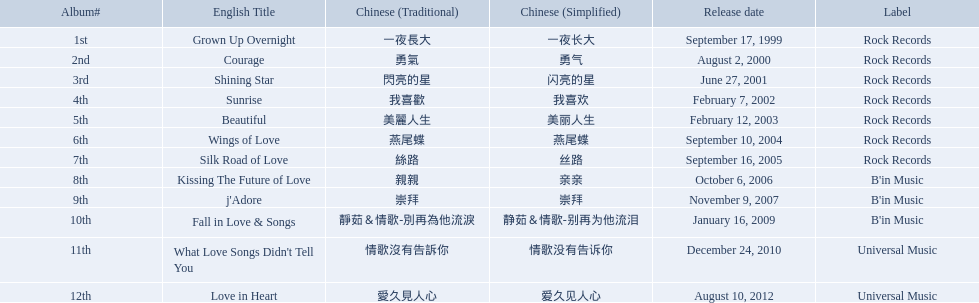Which english titles were released during even years? Courage, Sunrise, Silk Road of Love, Kissing The Future of Love, What Love Songs Didn't Tell You, Love in Heart. Out of the following, which one was released under b's in music? Kissing The Future of Love. Parse the full table in json format. {'header': ['Album#', 'English Title', 'Chinese (Traditional)', 'Chinese (Simplified)', 'Release date', 'Label'], 'rows': [['1st', 'Grown Up Overnight', '一夜長大', '一夜长大', 'September 17, 1999', 'Rock Records'], ['2nd', 'Courage', '勇氣', '勇气', 'August 2, 2000', 'Rock Records'], ['3rd', 'Shining Star', '閃亮的星', '闪亮的星', 'June 27, 2001', 'Rock Records'], ['4th', 'Sunrise', '我喜歡', '我喜欢', 'February 7, 2002', 'Rock Records'], ['5th', 'Beautiful', '美麗人生', '美丽人生', 'February 12, 2003', 'Rock Records'], ['6th', 'Wings of Love', '燕尾蝶', '燕尾蝶', 'September 10, 2004', 'Rock Records'], ['7th', 'Silk Road of Love', '絲路', '丝路', 'September 16, 2005', 'Rock Records'], ['8th', 'Kissing The Future of Love', '親親', '亲亲', 'October 6, 2006', "B'in Music"], ['9th', "j'Adore", '崇拜', '崇拜', 'November 9, 2007', "B'in Music"], ['10th', 'Fall in Love & Songs', '靜茹＆情歌-別再為他流淚', '静茹＆情歌-别再为他流泪', 'January 16, 2009', "B'in Music"], ['11th', "What Love Songs Didn't Tell You", '情歌沒有告訴你', '情歌没有告诉你', 'December 24, 2010', 'Universal Music'], ['12th', 'Love in Heart', '愛久見人心', '爱久见人心', 'August 10, 2012', 'Universal Music']]} Which songs did b'in music produce? Kissing The Future of Love, j'Adore, Fall in Love & Songs. Which one was released in an even numbered year? Kissing The Future of Love. Which tracks did b'in music create? Kissing The Future of Love, j'Adore, Fall in Love & Songs. Which one came out in an even-numbered year? Kissing The Future of Love. What were the records? Grown Up Overnight, Courage, Shining Star, Sunrise, Beautiful, Wings of Love, Silk Road of Love, Kissing The Future of Love, j'Adore, Fall in Love & Songs, What Love Songs Didn't Tell You, Love in Heart. Which ones were launched by b'in music? Kissing The Future of Love, j'Adore. Of these, which one was in an evenly-numbered year? Kissing The Future of Love. Which melodies were produced by b'in music? Kissing The Future of Love, j'Adore, Fall in Love & Songs. Which one was launched in an even-numbered year? Kissing The Future of Love. Which english titles came out in even years? Courage, Sunrise, Silk Road of Love, Kissing The Future of Love, What Love Songs Didn't Tell You, Love in Heart. Among the given options, which one was launched under the category of "b's" in music? Kissing The Future of Love. Could you help me parse every detail presented in this table? {'header': ['Album#', 'English Title', 'Chinese (Traditional)', 'Chinese (Simplified)', 'Release date', 'Label'], 'rows': [['1st', 'Grown Up Overnight', '一夜長大', '一夜长大', 'September 17, 1999', 'Rock Records'], ['2nd', 'Courage', '勇氣', '勇气', 'August 2, 2000', 'Rock Records'], ['3rd', 'Shining Star', '閃亮的星', '闪亮的星', 'June 27, 2001', 'Rock Records'], ['4th', 'Sunrise', '我喜歡', '我喜欢', 'February 7, 2002', 'Rock Records'], ['5th', 'Beautiful', '美麗人生', '美丽人生', 'February 12, 2003', 'Rock Records'], ['6th', 'Wings of Love', '燕尾蝶', '燕尾蝶', 'September 10, 2004', 'Rock Records'], ['7th', 'Silk Road of Love', '絲路', '丝路', 'September 16, 2005', 'Rock Records'], ['8th', 'Kissing The Future of Love', '親親', '亲亲', 'October 6, 2006', "B'in Music"], ['9th', "j'Adore", '崇拜', '崇拜', 'November 9, 2007', "B'in Music"], ['10th', 'Fall in Love & Songs', '靜茹＆情歌-別再為他流淚', '静茹＆情歌-别再为他流泪', 'January 16, 2009', "B'in Music"], ['11th', "What Love Songs Didn't Tell You", '情歌沒有告訴你', '情歌没有告诉你', 'December 24, 2010', 'Universal Music'], ['12th', 'Love in Heart', '愛久見人心', '爱久见人心', 'August 10, 2012', 'Universal Music']]} In even years, which english titles were released? Courage, Sunrise, Silk Road of Love, Kissing The Future of Love, What Love Songs Didn't Tell You, Love in Heart. From the listed choices, which one falls under the "b's" section in music? Kissing The Future of Love. Can you list the albums? Grown Up Overnight, Courage, Shining Star, Sunrise, Beautiful, Wings of Love, Silk Road of Love, Kissing The Future of Love, j'Adore, Fall in Love & Songs, What Love Songs Didn't Tell You, Love in Heart. Which ones were produced by b'in music? Kissing The Future of Love, j'Adore. Among them, which one was made available in an even-numbered year? Kissing The Future of Love. 